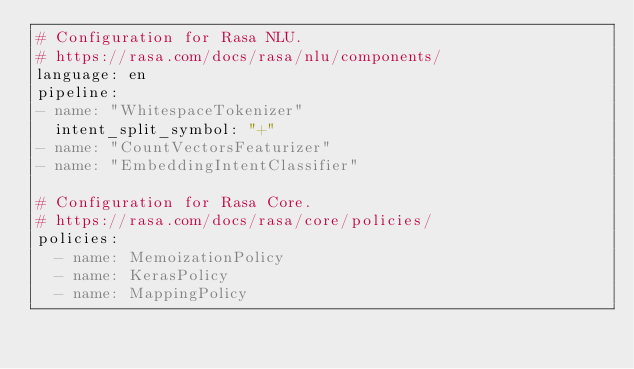Convert code to text. <code><loc_0><loc_0><loc_500><loc_500><_YAML_># Configuration for Rasa NLU.
# https://rasa.com/docs/rasa/nlu/components/
language: en
pipeline:
- name: "WhitespaceTokenizer"
  intent_split_symbol: "+"
- name: "CountVectorsFeaturizer"
- name: "EmbeddingIntentClassifier"

# Configuration for Rasa Core.
# https://rasa.com/docs/rasa/core/policies/
policies:
  - name: MemoizationPolicy
  - name: KerasPolicy
  - name: MappingPolicy
</code> 